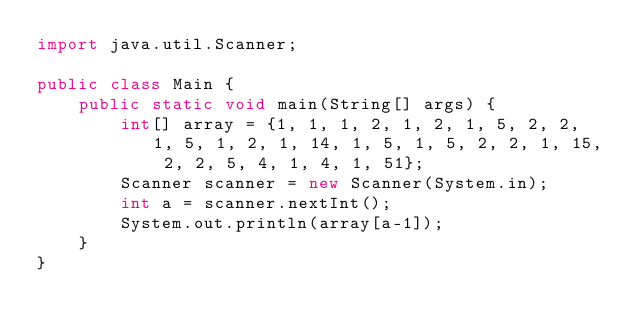<code> <loc_0><loc_0><loc_500><loc_500><_Java_>import java.util.Scanner;

public class Main {
    public static void main(String[] args) {
        int[] array = {1, 1, 1, 2, 1, 2, 1, 5, 2, 2, 1, 5, 1, 2, 1, 14, 1, 5, 1, 5, 2, 2, 1, 15, 2, 2, 5, 4, 1, 4, 1, 51};
        Scanner scanner = new Scanner(System.in);
        int a = scanner.nextInt();
        System.out.println(array[a-1]);
    }
}
</code> 